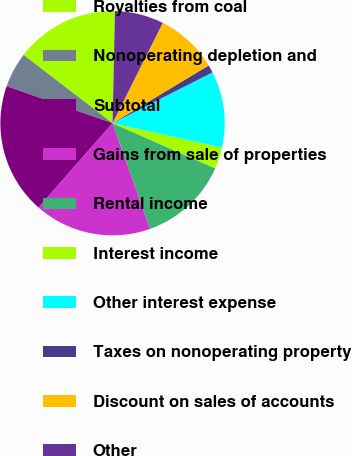Convert chart to OTSL. <chart><loc_0><loc_0><loc_500><loc_500><pie_chart><fcel>Royalties from coal<fcel>Nonoperating depletion and<fcel>Subtotal<fcel>Gains from sale of properties<fcel>Rental income<fcel>Interest income<fcel>Other interest expense<fcel>Taxes on nonoperating property<fcel>Discount on sales of accounts<fcel>Other<nl><fcel>14.93%<fcel>5.07%<fcel>18.88%<fcel>16.91%<fcel>12.96%<fcel>3.09%<fcel>10.99%<fcel>1.12%<fcel>9.01%<fcel>7.04%<nl></chart> 